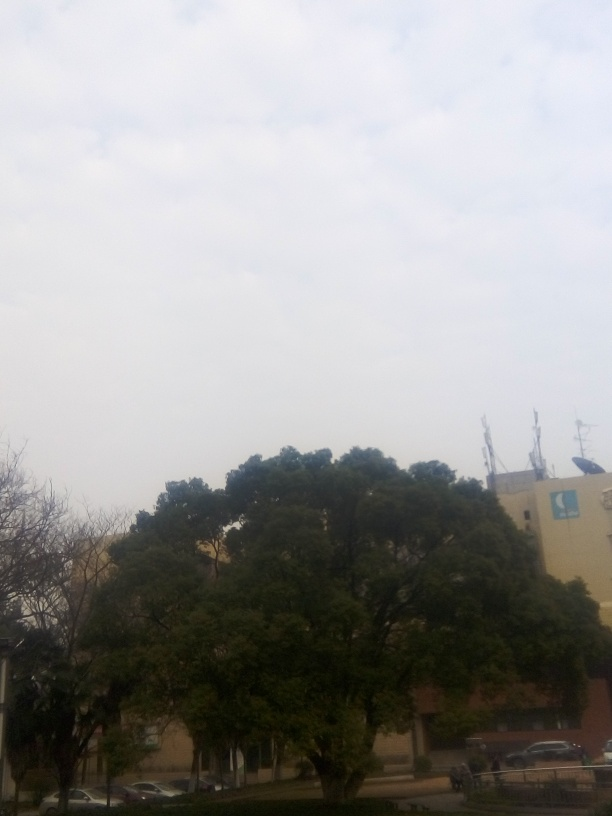How would you describe the composition of this image? The image presents an urban scene with a lush assortment of trees in the foreground. Your eye might catch the juxtaposition of natural greenery against a clear sky, overshadowed by the presence of a nondescript building in the background. The overcast sky provides a soft, diffused light, which conveys a calm and tranquil atmosphere within what appears to be a city environment. 